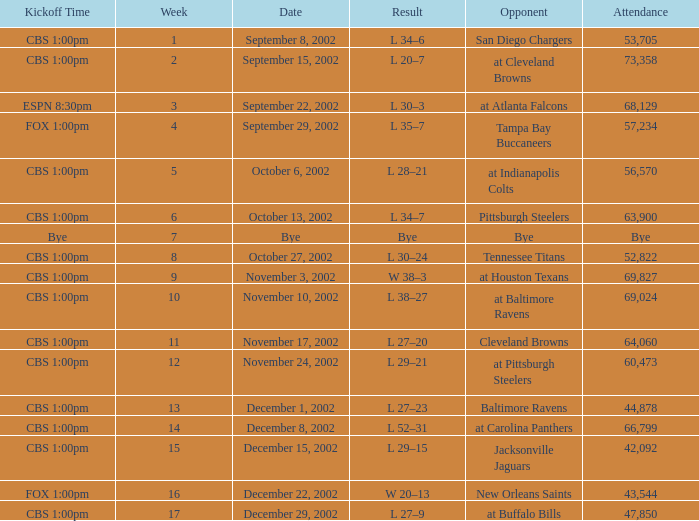Would you be able to parse every entry in this table? {'header': ['Kickoff Time', 'Week', 'Date', 'Result', 'Opponent', 'Attendance'], 'rows': [['CBS 1:00pm', '1', 'September 8, 2002', 'L 34–6', 'San Diego Chargers', '53,705'], ['CBS 1:00pm', '2', 'September 15, 2002', 'L 20–7', 'at Cleveland Browns', '73,358'], ['ESPN 8:30pm', '3', 'September 22, 2002', 'L 30–3', 'at Atlanta Falcons', '68,129'], ['FOX 1:00pm', '4', 'September 29, 2002', 'L 35–7', 'Tampa Bay Buccaneers', '57,234'], ['CBS 1:00pm', '5', 'October 6, 2002', 'L 28–21', 'at Indianapolis Colts', '56,570'], ['CBS 1:00pm', '6', 'October 13, 2002', 'L 34–7', 'Pittsburgh Steelers', '63,900'], ['Bye', '7', 'Bye', 'Bye', 'Bye', 'Bye'], ['CBS 1:00pm', '8', 'October 27, 2002', 'L 30–24', 'Tennessee Titans', '52,822'], ['CBS 1:00pm', '9', 'November 3, 2002', 'W 38–3', 'at Houston Texans', '69,827'], ['CBS 1:00pm', '10', 'November 10, 2002', 'L 38–27', 'at Baltimore Ravens', '69,024'], ['CBS 1:00pm', '11', 'November 17, 2002', 'L 27–20', 'Cleveland Browns', '64,060'], ['CBS 1:00pm', '12', 'November 24, 2002', 'L 29–21', 'at Pittsburgh Steelers', '60,473'], ['CBS 1:00pm', '13', 'December 1, 2002', 'L 27–23', 'Baltimore Ravens', '44,878'], ['CBS 1:00pm', '14', 'December 8, 2002', 'L 52–31', 'at Carolina Panthers', '66,799'], ['CBS 1:00pm', '15', 'December 15, 2002', 'L 29–15', 'Jacksonville Jaguars', '42,092'], ['FOX 1:00pm', '16', 'December 22, 2002', 'W 20–13', 'New Orleans Saints', '43,544'], ['CBS 1:00pm', '17', 'December 29, 2002', 'L 27–9', 'at Buffalo Bills', '47,850']]} How many people attended the game with a kickoff time of cbs 1:00pm, in a week earlier than 8, on September 15, 2002? 73358.0. 